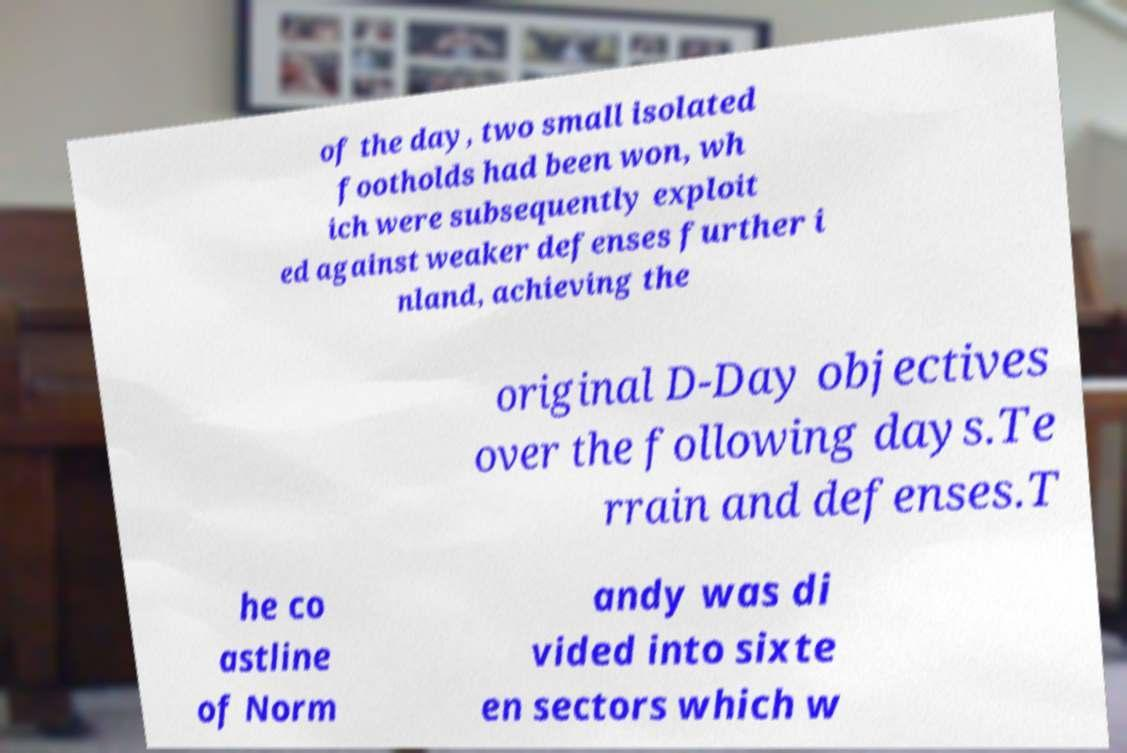Can you read and provide the text displayed in the image?This photo seems to have some interesting text. Can you extract and type it out for me? of the day, two small isolated footholds had been won, wh ich were subsequently exploit ed against weaker defenses further i nland, achieving the original D-Day objectives over the following days.Te rrain and defenses.T he co astline of Norm andy was di vided into sixte en sectors which w 